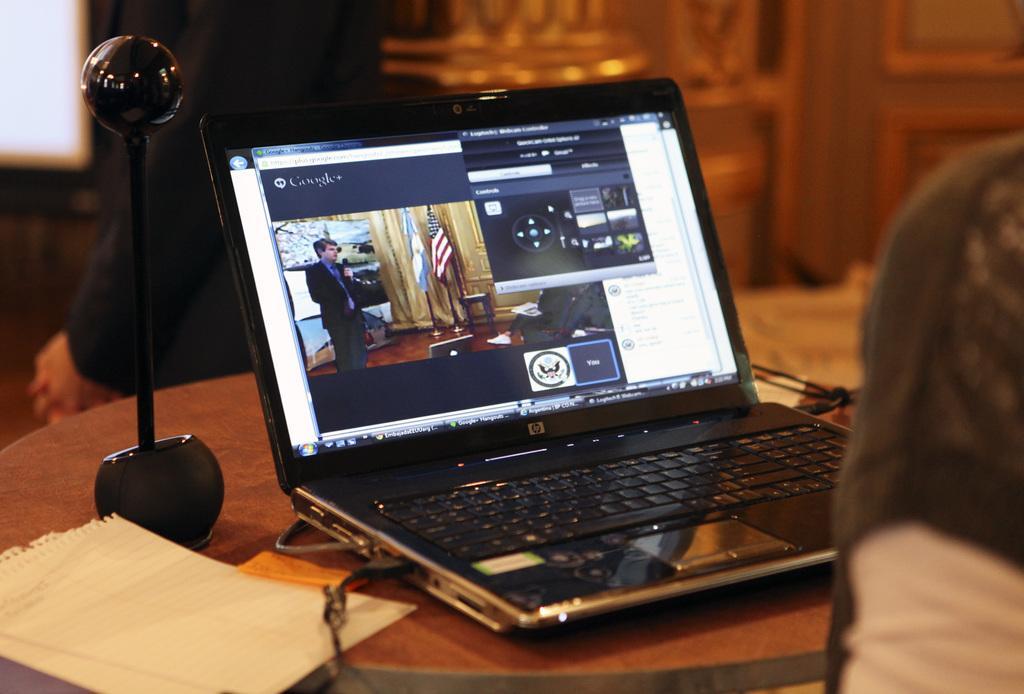Can you describe this image briefly? In this image, we can see a laptop on the table. There is an object on the left side of the image. There is a paper in the bottom left of the image. In the background, image is blurred. 